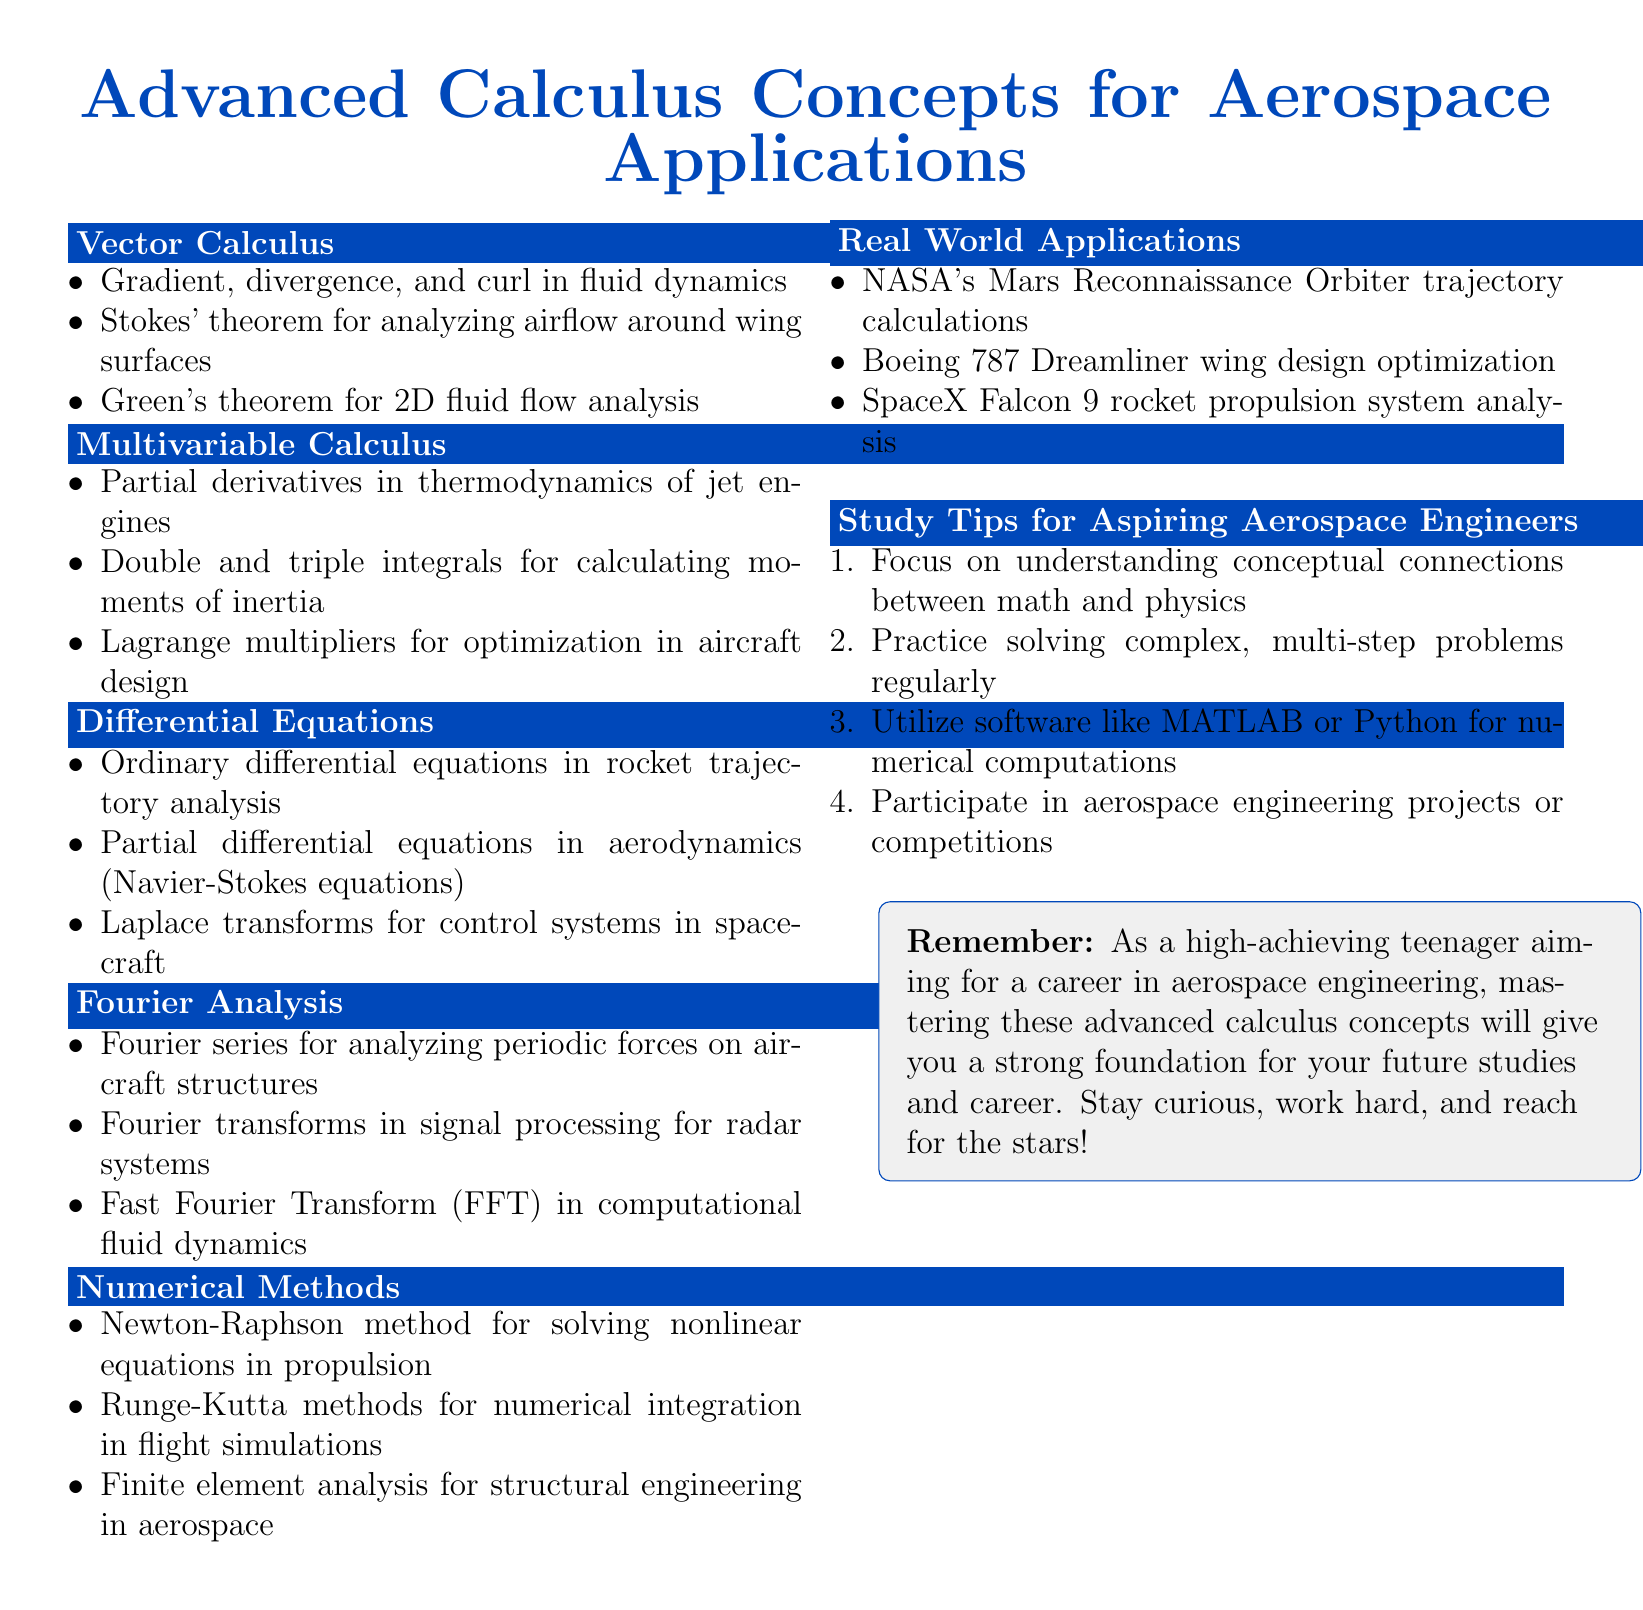What are the key topics covered in vector calculus? The document lists the key points related to vector calculus, including gradient, divergence, and curl in fluid dynamics, Stokes' theorem, and Green's theorem.
Answer: Gradient, divergence, and curl in fluid dynamics; Stokes' theorem; Green's theorem What is one application of differential equations in aerospace engineering? The document mentions the use of ordinary differential equations in rocket trajectory analysis as an application of differential equations.
Answer: Rocket trajectory analysis Which method is used for numerical integration in flight simulations? The document highlights Runge-Kutta methods as a method for numerical integration in flight simulations.
Answer: Runge-Kutta methods Name one study tip for aspiring aerospace engineers. The document provides several study tips, including focusing on conceptual connections between math and physics or practicing solving complex problems.
Answer: Focus on understanding conceptual connections between math and physics What theorem is highlighted for analyzing airflow around wing surfaces? The document indicates Stokes' theorem as the theorem used for analyzing airflow around wing surfaces.
Answer: Stokes' theorem Which transformation is utilized for control systems in spacecraft? The document identifies Laplace transforms as the method used in control systems for spacecraft.
Answer: Laplace transforms What numerical method is mentioned for solving nonlinear equations in propulsion? The document lists the Newton-Raphson method as the numerical method for solving nonlinear equations in propulsion.
Answer: Newton-Raphson method What major aerospace application is associated with the Mars Reconnaissance Orbiter? The document states the Mars Reconnaissance Orbiter is involved in trajectory calculations.
Answer: Trajectory calculations How many key points are listed under multivariable calculus? The document indicates that there are three key points listed under multivariable calculus.
Answer: Three 